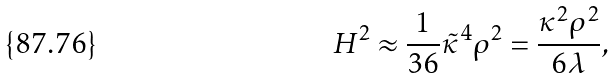Convert formula to latex. <formula><loc_0><loc_0><loc_500><loc_500>H ^ { 2 } \approx \frac { 1 } { 3 6 } \tilde { \kappa } ^ { 4 } \rho ^ { 2 } = \frac { \kappa ^ { 2 } \rho ^ { 2 } } { 6 \lambda } ,</formula> 